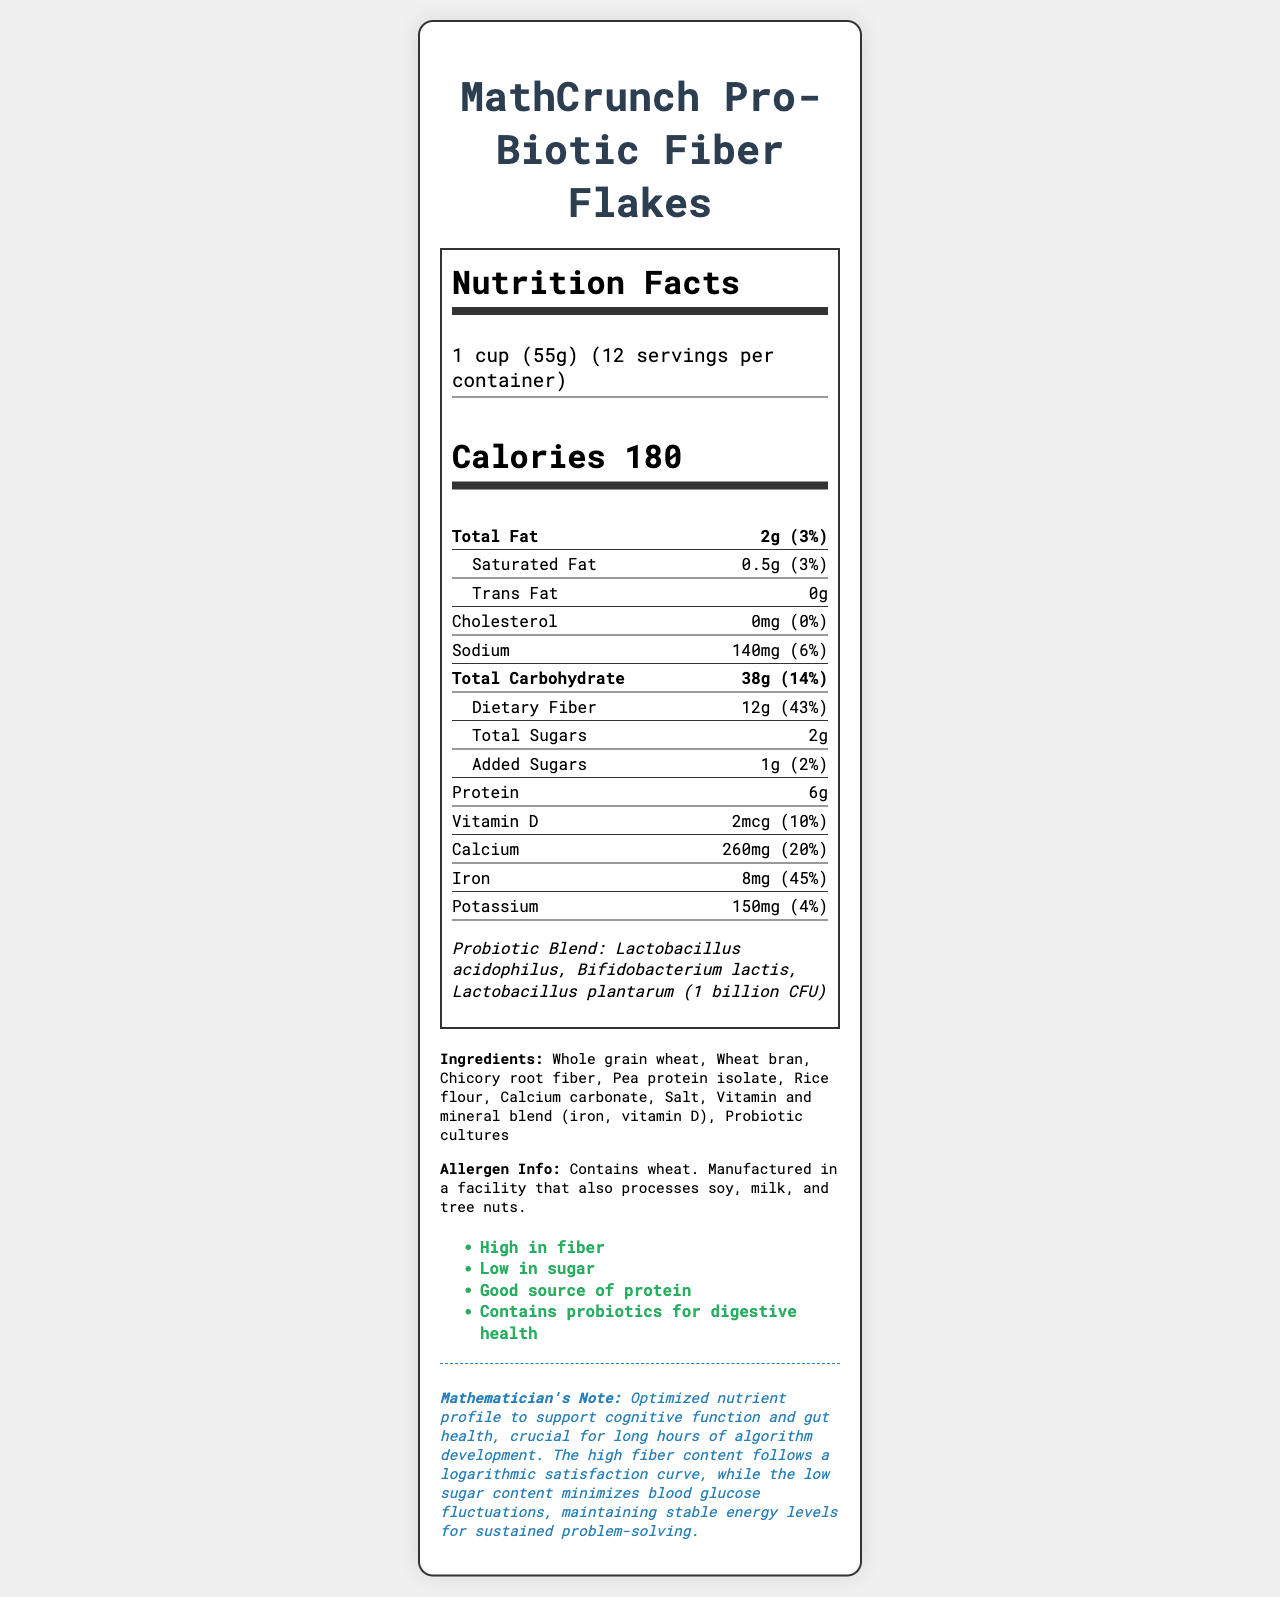What is the serving size of MathCrunch Pro-Biotic Fiber Flakes? The serving size is listed at the top of the Nutrition Facts under "Serving Size".
Answer: 1 cup (55g) How many calories are in one serving? The calories per serving are explicitly listed as 180 in the document.
Answer: 180 What percentage of the daily value of dietary fiber does one serving provide? The document lists the dietary fiber as providing 43% of the daily value per serving.
Answer: 43% Which probiotic strains are included in MathCrunch Pro-Biotic Fiber Flakes? The document specifically mentions these strains under the Probiotic Blend section.
Answer: Lactobacillus acidophilus, Bifidobacterium lactis, Lactobacillus plantarum What is the total carbohydrate content per serving? The total carbohydrate content per serving is listed as 38g in the Nutrition Facts section.
Answer: 38g Is this cereal low in sugar? (Yes/No) The claim statements include "Low in sugar", and the total sugars per serving is 2g with only 1g of added sugars.
Answer: Yes What is the amount of protein per serving? The amount of protein per serving is listed as 6g in the document.
Answer: 6g MathCrunch Pro-Biotic Fiber Flakes are manufactured in a facility that also processes which allergens? The allergen information states that the product is manufactured in a facility that processes soy, milk, and tree nuts.
Answer: Soy, milk, tree nuts Which of the following minerals is highest in daily value contribution per serving? 
A. Calcium 
B. Iron 
C. Potassium 
D. Vitamin D Iron has the highest daily value contribution at 45% per serving.
Answer: B How much vitamin D is present in each serving? 
I. 1mcg 
II. 2mcg 
III. 4mcg 
IV. 8mcg The document states that there is 2mcg of vitamin D per serving.
Answer: II. 2mcg Describe the main idea of the Nutrition Facts Label for MathCrunch Pro-Biotic Fiber Flakes. This summary covers the key attributes of the product as detailed in the Nutrition Facts Label, including its purpose and benefits.
Answer: The document provides comprehensive nutritional information about MathCrunch Pro-Biotic Fiber Flakes, highlighting its high fiber, low sugar content, and the inclusion of probiotics for digestive health. It also outlines the ingredients, allergen information, and specific nutrient contributions to daily values to support cognitive function and gut health. What is the logarithmic satisfaction curve in relation to fiber content? The document does not provide detailed information on what the logarithmic satisfaction curve specifically entails in the context of fiber content.
Answer: Not enough information How many calories come from fat in one serving? The document does not break down the calorie content into calories from fat directly.
Answer: Cannot be determined Does the cereal contain any trans fat? The Nutrition Facts section lists the amount of trans fat as 0g.
Answer: No Which vitamins and minerals are included in the vitamin and mineral blend? The ingredients list specifies a vitamin and mineral blend containing iron and vitamin D.
Answer: Iron, Vitamin D 